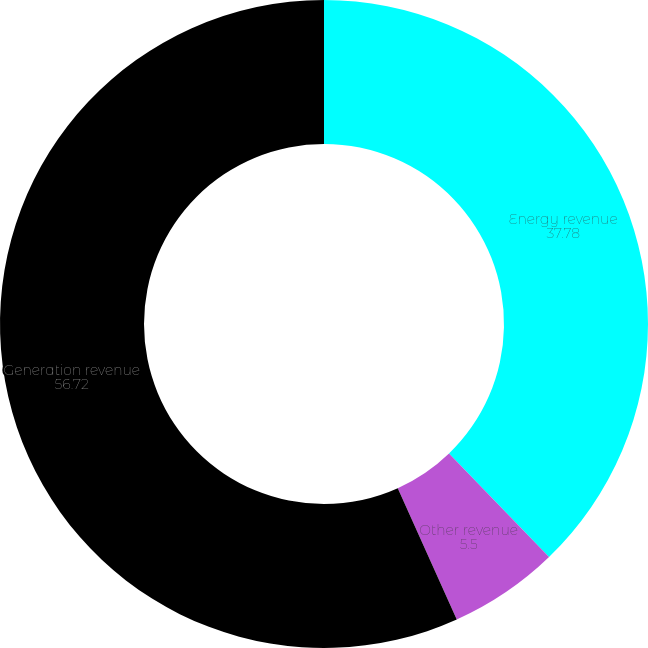<chart> <loc_0><loc_0><loc_500><loc_500><pie_chart><fcel>Energy revenue<fcel>Other revenue<fcel>Generation revenue<nl><fcel>37.78%<fcel>5.5%<fcel>56.72%<nl></chart> 